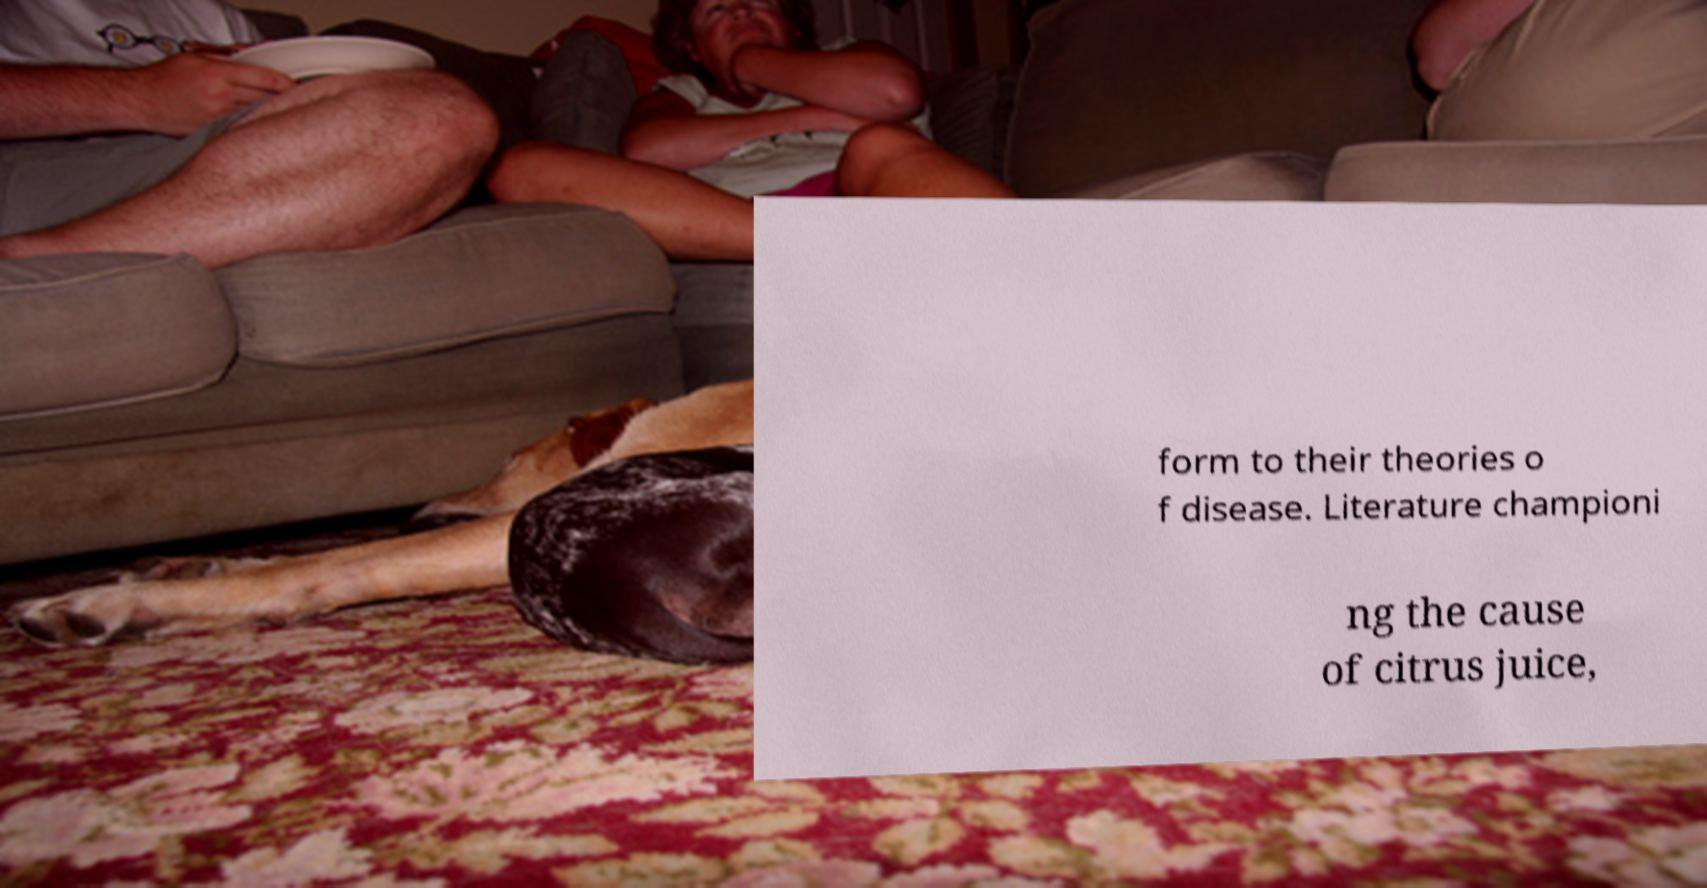Please read and relay the text visible in this image. What does it say? form to their theories o f disease. Literature championi ng the cause of citrus juice, 